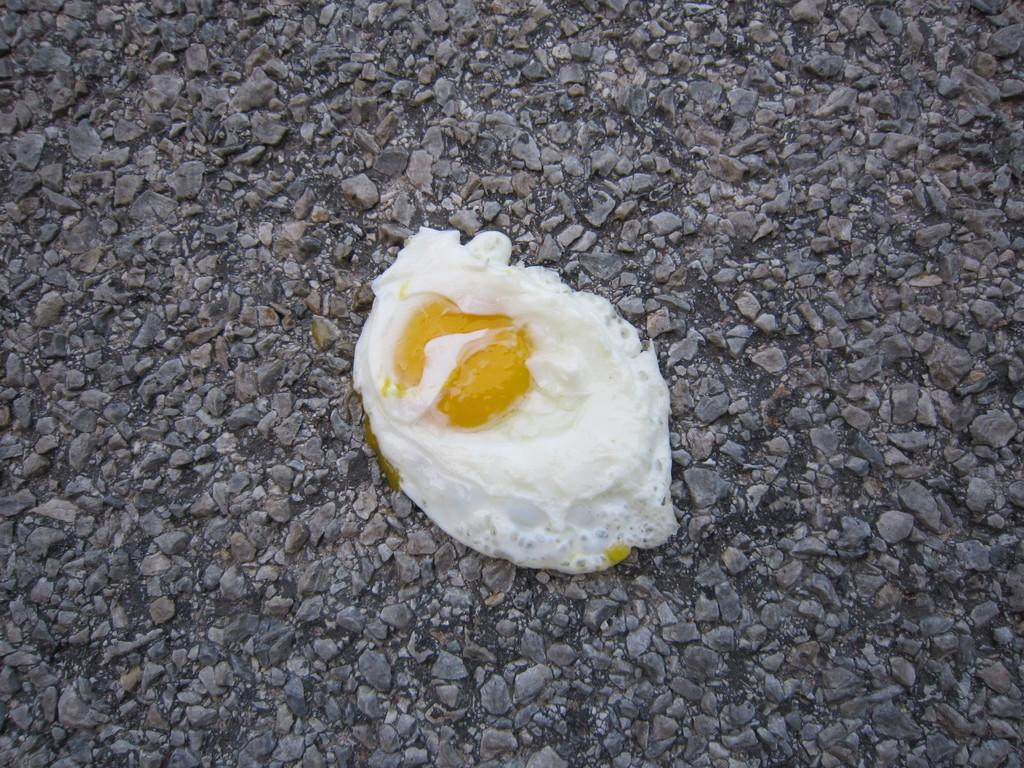What is the main subject of the image? The main subject of the image is a poached egg. Where is the poached egg located? The poached egg is on a stone surface. What theory is being proposed by the ducks in the image? There are no ducks present in the image, so no theory can be proposed by them. 